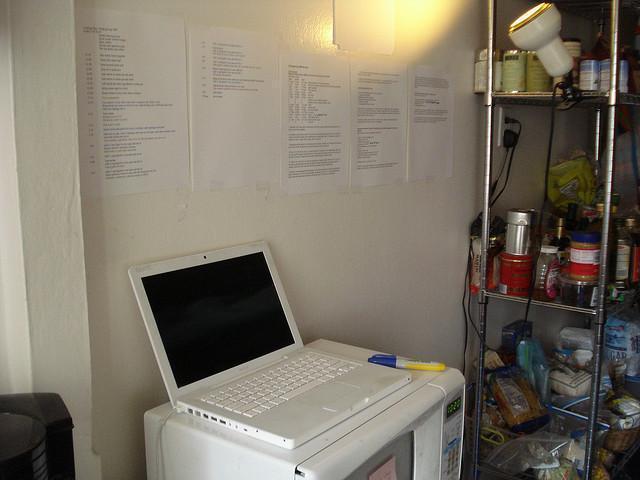How many elephants are there?
Give a very brief answer. 0. 